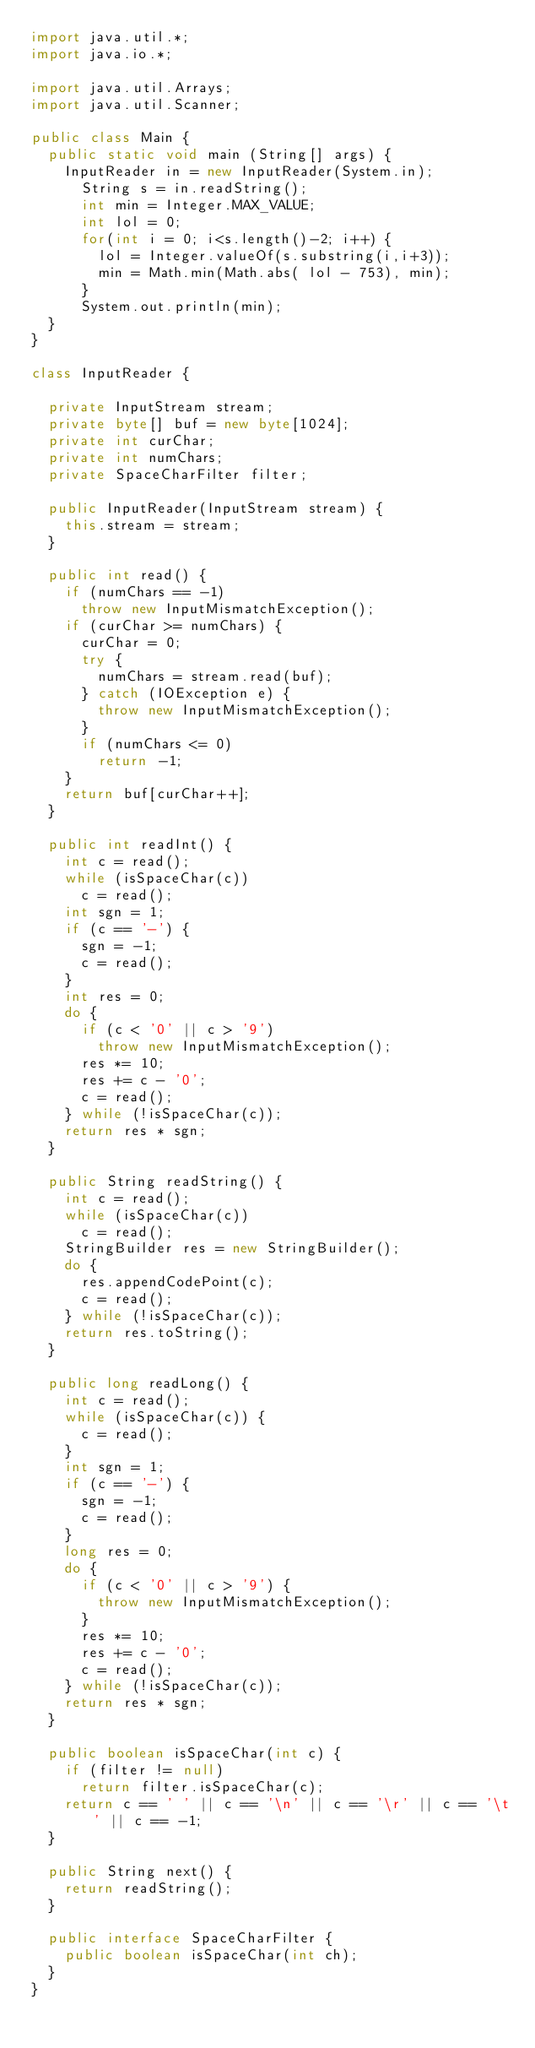Convert code to text. <code><loc_0><loc_0><loc_500><loc_500><_Java_>import java.util.*;
import java.io.*;

import java.util.Arrays;
import java.util.Scanner;

public class Main {
	public static void main (String[] args) {
		InputReader in = new InputReader(System.in);
	    String s = in.readString();
	    int min = Integer.MAX_VALUE;
	    int lol = 0; 
	    for(int i = 0; i<s.length()-2; i++) {
	    	lol = Integer.valueOf(s.substring(i,i+3));
	    	min = Math.min(Math.abs( lol - 753), min);
	    }
	    System.out.println(min);
	}
}

class InputReader {

	private InputStream stream;
	private byte[] buf = new byte[1024];
	private int curChar;
	private int numChars;
	private SpaceCharFilter filter;

	public InputReader(InputStream stream) {
		this.stream = stream;
	}

	public int read() {
		if (numChars == -1)
			throw new InputMismatchException();
		if (curChar >= numChars) {
			curChar = 0;
			try {
				numChars = stream.read(buf);
			} catch (IOException e) {
				throw new InputMismatchException();
			}
			if (numChars <= 0)
				return -1;
		}
		return buf[curChar++];
	}

	public int readInt() {
		int c = read();
		while (isSpaceChar(c))
			c = read();
		int sgn = 1;
		if (c == '-') {
			sgn = -1;
			c = read();
		}
		int res = 0;
		do {
			if (c < '0' || c > '9')
				throw new InputMismatchException();
			res *= 10;
			res += c - '0';
			c = read();
		} while (!isSpaceChar(c));
		return res * sgn;
	}

	public String readString() {
		int c = read();
		while (isSpaceChar(c))
			c = read();
		StringBuilder res = new StringBuilder();
		do {
			res.appendCodePoint(c);
			c = read();
		} while (!isSpaceChar(c));
		return res.toString();
	}

	public long readLong() {
		int c = read();
		while (isSpaceChar(c)) {
			c = read();
		}
		int sgn = 1;
		if (c == '-') {
			sgn = -1;
			c = read();
		}
		long res = 0;
		do {
			if (c < '0' || c > '9') {
				throw new InputMismatchException();
			}
			res *= 10;
			res += c - '0';
			c = read();
		} while (!isSpaceChar(c));
		return res * sgn;
	}
	
	public boolean isSpaceChar(int c) {
		if (filter != null)
			return filter.isSpaceChar(c);
		return c == ' ' || c == '\n' || c == '\r' || c == '\t' || c == -1;
	}

	public String next() {
		return readString();
	}

	public interface SpaceCharFilter {
		public boolean isSpaceChar(int ch);
	}
}
</code> 